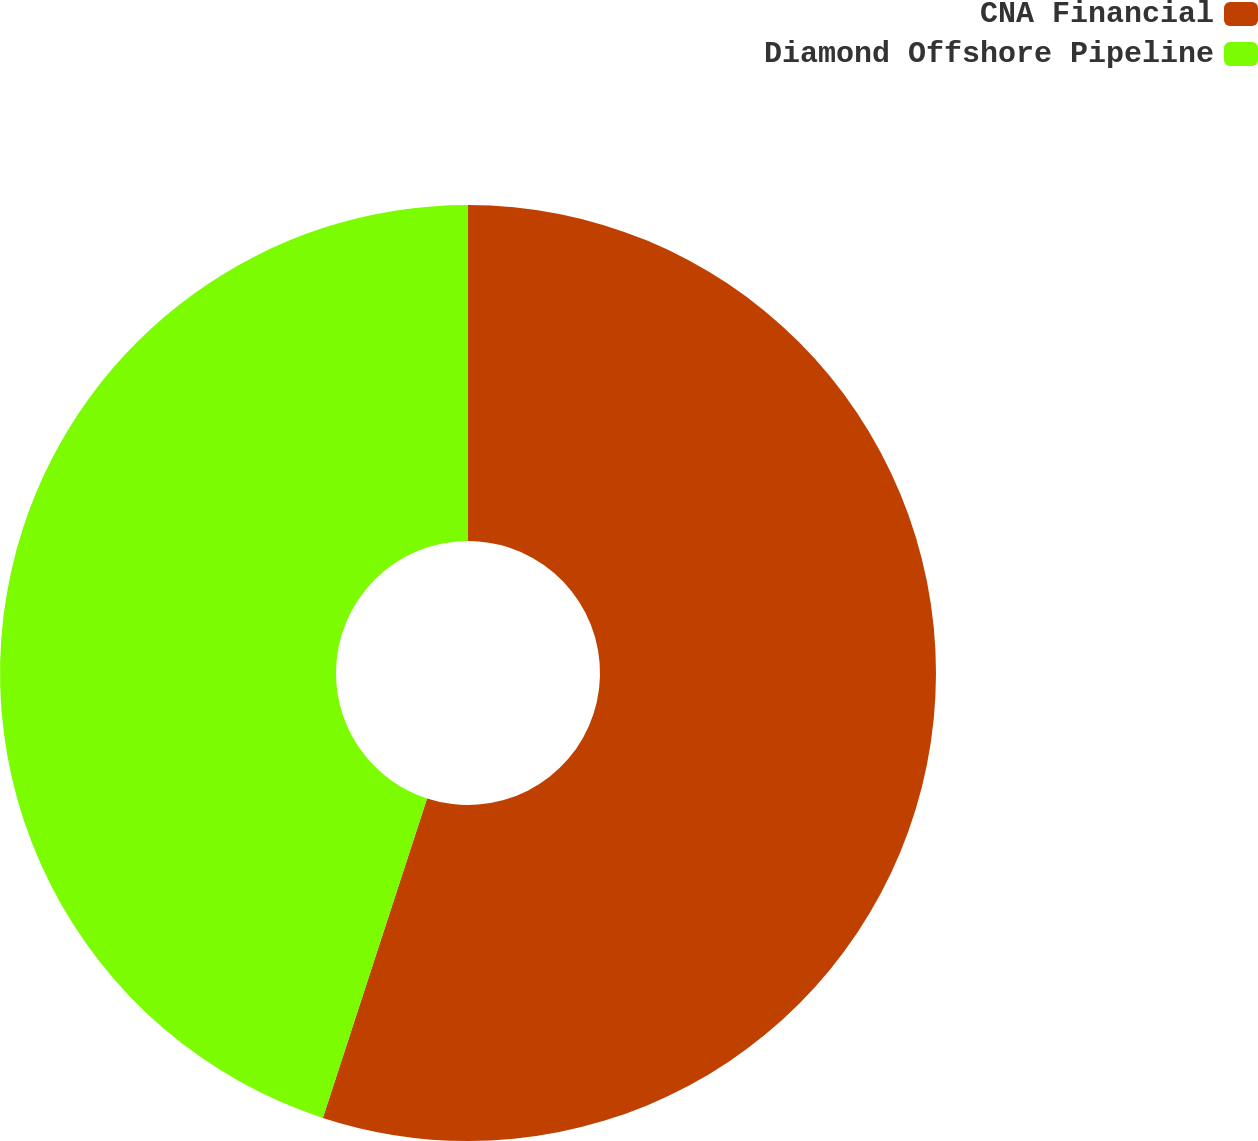<chart> <loc_0><loc_0><loc_500><loc_500><pie_chart><fcel>CNA Financial<fcel>Diamond Offshore Pipeline<nl><fcel>55.02%<fcel>44.98%<nl></chart> 